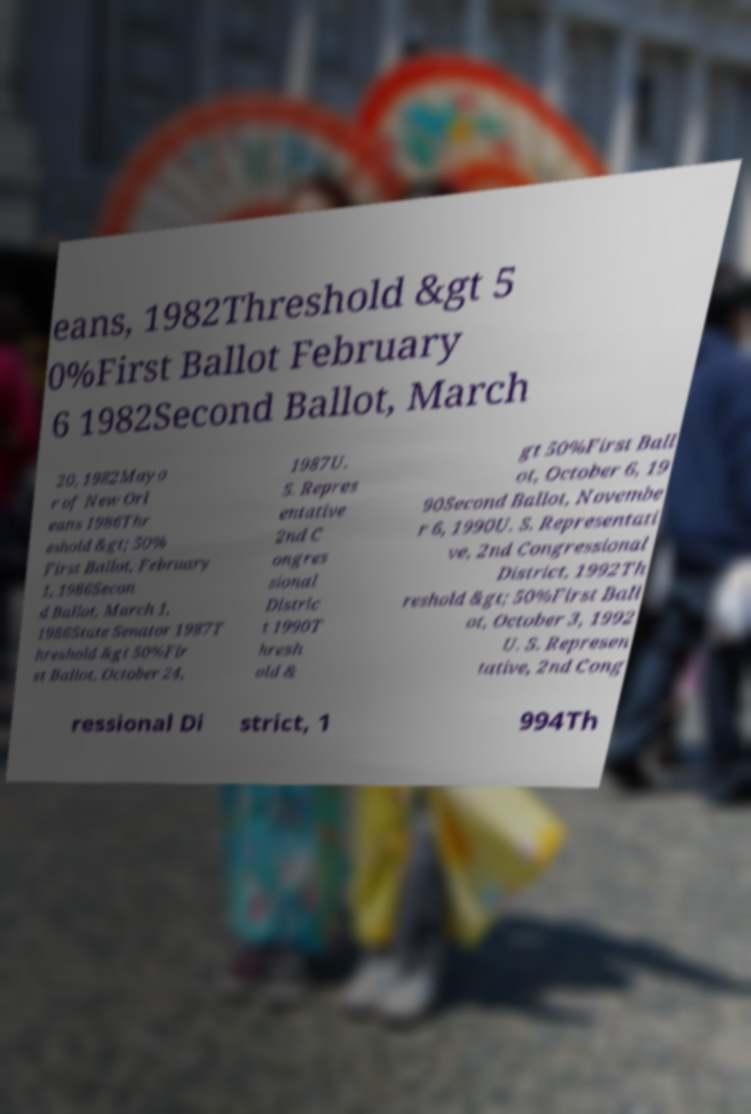There's text embedded in this image that I need extracted. Can you transcribe it verbatim? eans, 1982Threshold &gt 5 0%First Ballot February 6 1982Second Ballot, March 20, 1982Mayo r of New Orl eans 1986Thr eshold &gt; 50% First Ballot, February 1, 1986Secon d Ballot, March 1, 1986State Senator 1987T hreshold &gt 50%Fir st Ballot, October 24, 1987U. S. Repres entative 2nd C ongres sional Distric t 1990T hresh old & gt 50%First Ball ot, October 6, 19 90Second Ballot, Novembe r 6, 1990U. S. Representati ve, 2nd Congressional District, 1992Th reshold &gt; 50%First Ball ot, October 3, 1992 U. S. Represen tative, 2nd Cong ressional Di strict, 1 994Th 